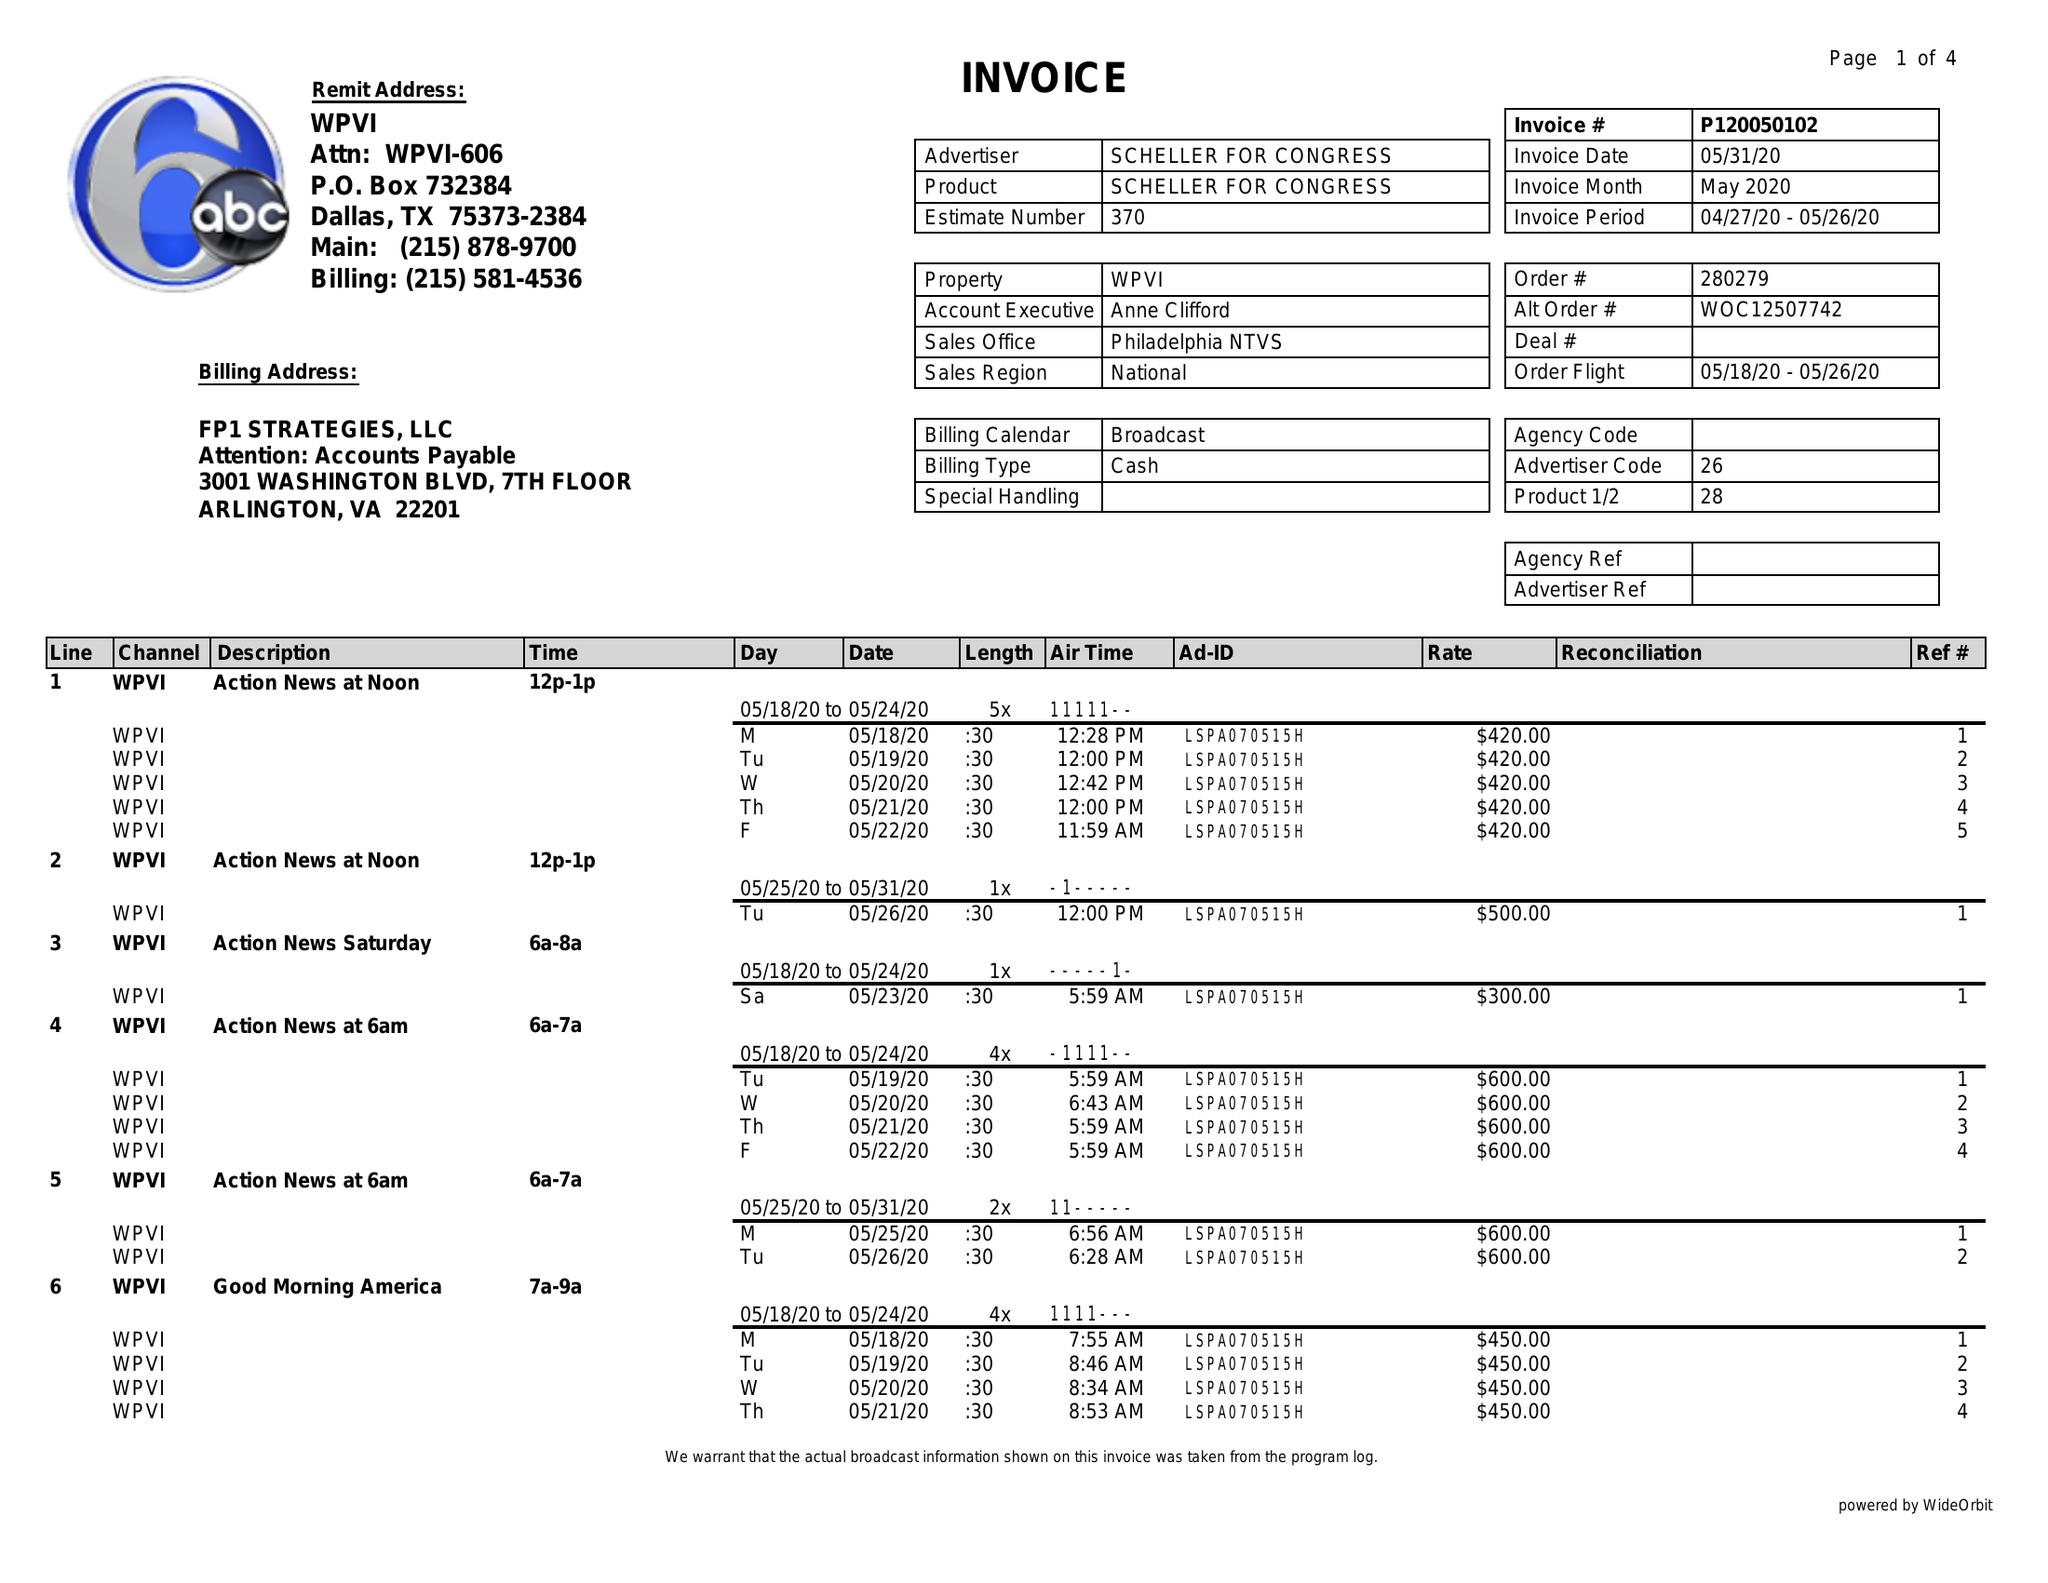What is the value for the flight_to?
Answer the question using a single word or phrase. 05/26/20 